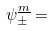<formula> <loc_0><loc_0><loc_500><loc_500>\psi _ { \pm } ^ { \underline { m } } =</formula> 